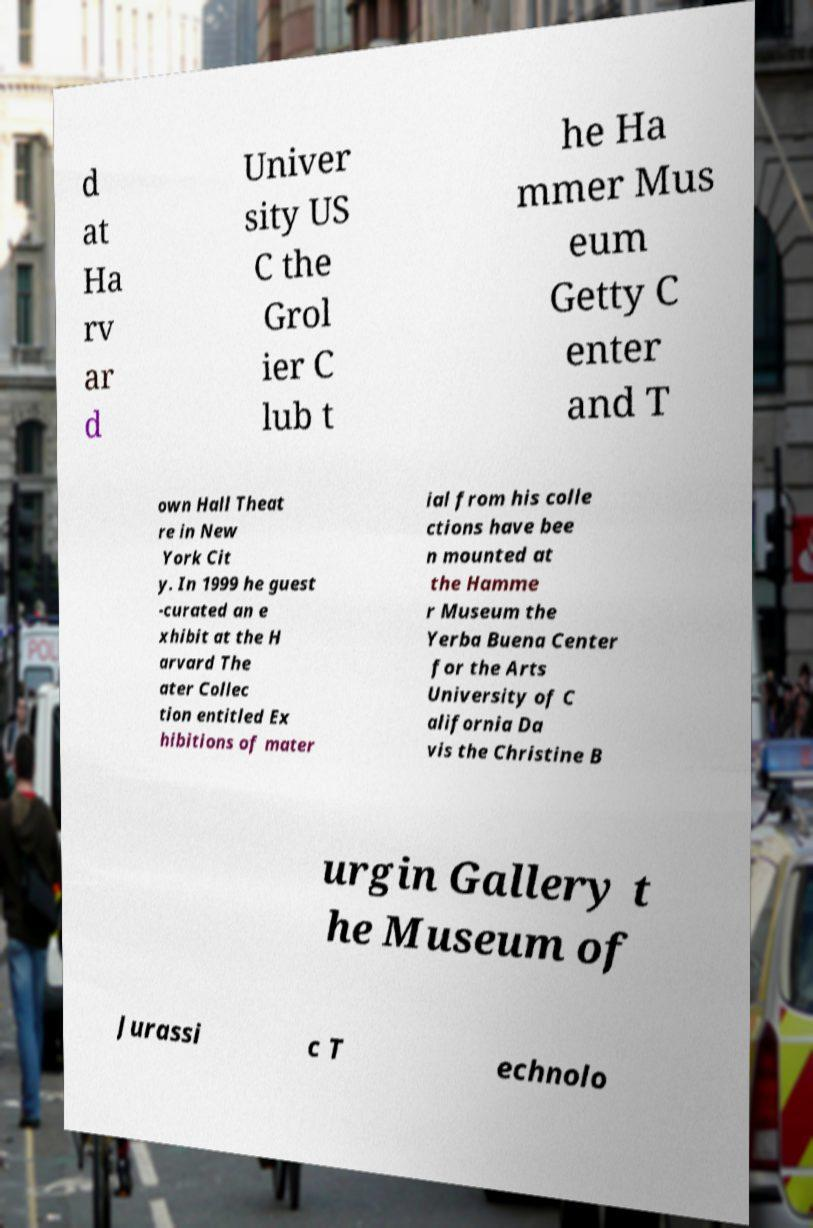Can you accurately transcribe the text from the provided image for me? d at Ha rv ar d Univer sity US C the Grol ier C lub t he Ha mmer Mus eum Getty C enter and T own Hall Theat re in New York Cit y. In 1999 he guest -curated an e xhibit at the H arvard The ater Collec tion entitled Ex hibitions of mater ial from his colle ctions have bee n mounted at the Hamme r Museum the Yerba Buena Center for the Arts University of C alifornia Da vis the Christine B urgin Gallery t he Museum of Jurassi c T echnolo 